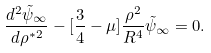Convert formula to latex. <formula><loc_0><loc_0><loc_500><loc_500>\frac { d ^ { 2 } \tilde { \psi } _ { \infty } } { d \rho ^ { * 2 } } - [ \frac { 3 } { 4 } - \mu ] \frac { \rho ^ { 2 } } { R ^ { 4 } } \tilde { \psi } _ { \infty } = 0 .</formula> 